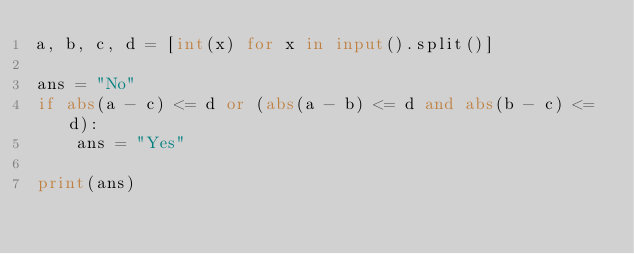<code> <loc_0><loc_0><loc_500><loc_500><_Python_>a, b, c, d = [int(x) for x in input().split()]

ans = "No"
if abs(a - c) <= d or (abs(a - b) <= d and abs(b - c) <= d):
    ans = "Yes"

print(ans)
</code> 